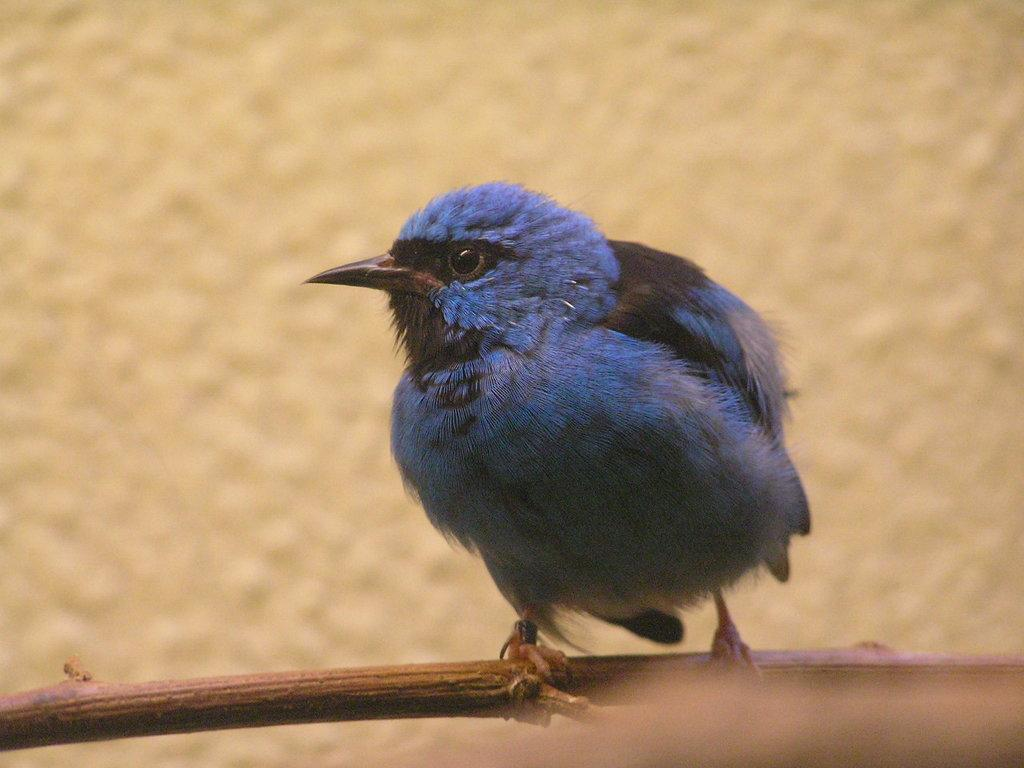What type of bird can be seen in the image? There is a purple color bird in the image. Where is the bird located in the image? The bird is on the branch of a tree. What color is the background of the image? The background of the image is in cream color. How many girls are resting under the tree in the image? There are no girls or resting individuals present in the image; it only features a purple color bird on the branch of a tree with a cream-colored background. 